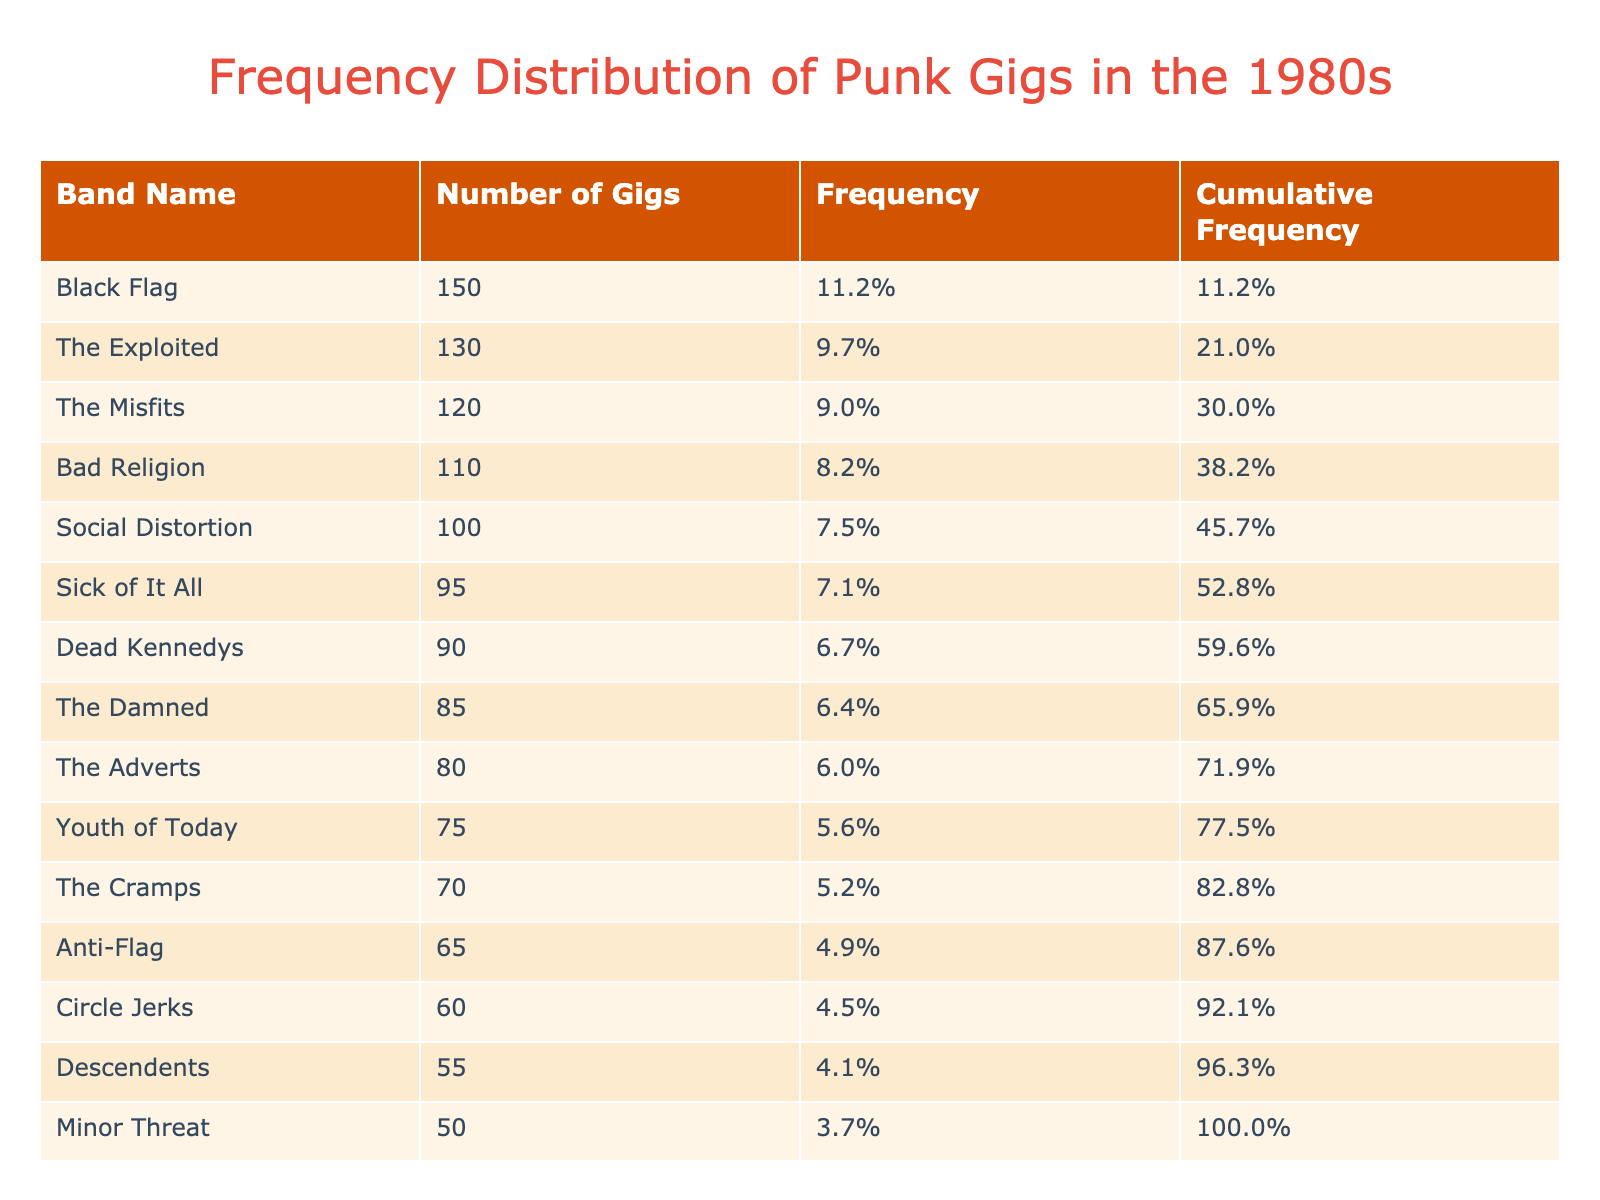What band played the most gigs in the 1980s? The band with the highest number of gigs listed in the table is 'Black Flag,' which played 150 gigs. This can be identified by looking for the maximum value in the 'Number of Gigs' column.
Answer: Black Flag How many gigs did The Cramps perform? The table indicates that 'The Cramps' performed 70 gigs, as seen directly in the corresponding row for that band.
Answer: 70 What is the total number of gigs played by all the bands? To find the total number of gigs, we sum the 'Number of Gigs' for all the bands. Adding them up gives us (120 + 150 + 90 + 110 + 130 + 80 + 95 + 70 + 100 + 85 + 75 + 65 + 60 + 55 + 50) = 1,205.
Answer: 1,205 Which band has a cumulative frequency above 60%? To find this, we refer to the 'Cumulative Frequency' column and check which bands exceed 60%. On reviewing the cumulative frequencies, 'The Misfits', 'Black Flag', 'The Exploited', 'Bad Religion', and 'Social Distortion' all have values exceeding 60%.
Answer: The Misfits, Black Flag, The Exploited, Bad Religion, Social Distortion What is the average number of gigs played by the bands listed? To find the average, we take the total number of gigs (1,205) and divide it by the number of bands, which is 15. Calculating 1,205 / 15 gives us an average of approximately 80.33.
Answer: 80.33 Did any bands play exactly 100 gigs? Checking the table, 'Social Distortion' is noted to have performed exactly 100 gigs. We can affirm this by identifying the precise number listed for that band.
Answer: Yes Which band played fewer gigs: Anti-Flag or Minor Threat? Looking at the table, 'Anti-Flag' played 65 gigs and 'Minor Threat' played 50 gigs. Comparing these two values shows that 'Minor Threat' played fewer gigs, as 50 is less than 65.
Answer: Minor Threat What percentage of total gigs did the Dead Kennedys represent? To find the percentage, we take the number of gigs for 'Dead Kennedys' (90) and divide it by the total number of gigs (1,205), multiplying the result by 100. The calculation is (90 / 1,205) * 100, which gives approximately 7.46%.
Answer: 7.46% Are there any bands that played more than 100 gigs? Checking the 'Number of Gigs' column shows that 'Black Flag', 'The Exploited', 'The Misfits', 'Bad Religion', and 'Social Distortion' all played more than 100 gigs. We conclude that there are multiple bands fitting this criterion.
Answer: Yes 